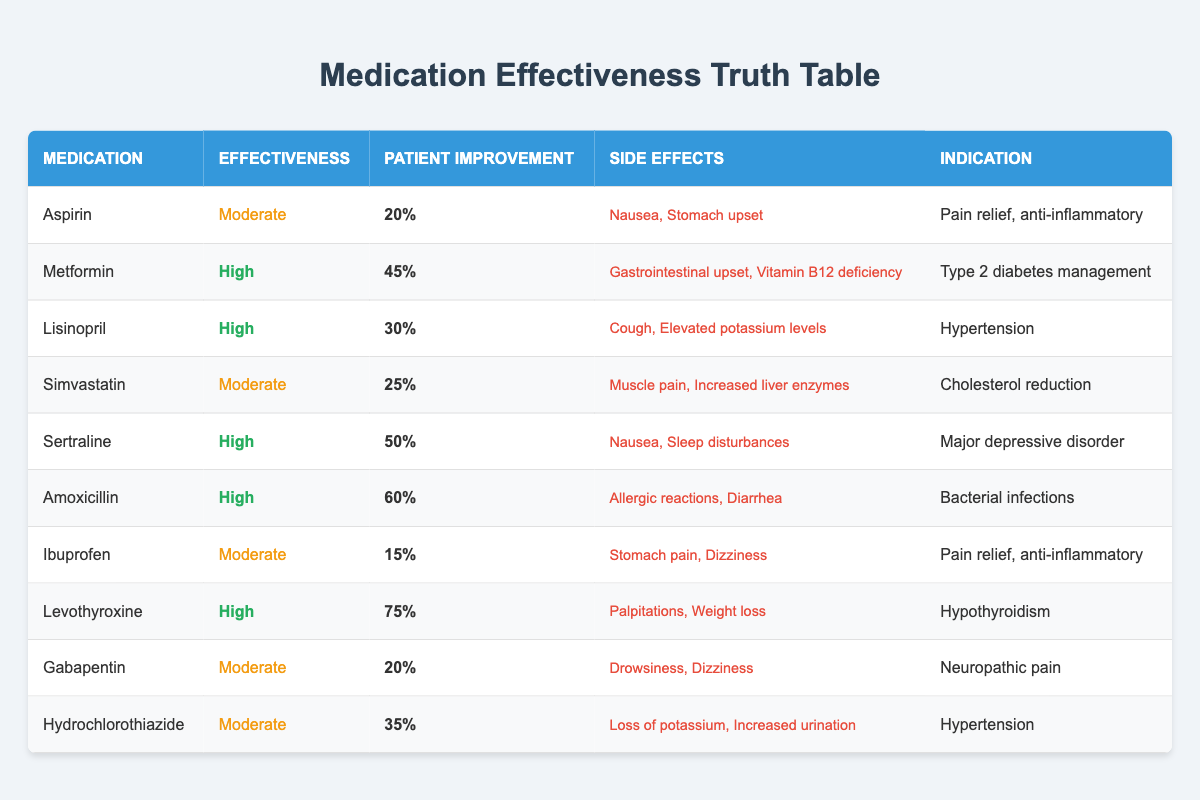What is the patient improvement percentage for Sertraline? The patient improvement percentage for Sertraline is found in the table under the "Patient Improvement" column next to Sertraline. It shows "50%".
Answer: 50% Which medication has the highest effectiveness rating? From the table, the effectiveness ratings are categorized as "High" and "Moderate." Scanning through the table, the medications that have a "High" effectiveness are Metformin, Lisinopril, Sertraline, Amoxicillin, and Levothyroxine. Therefore, there are multiple medications with the highest rating of "High".
Answer: Multiple medications have high effectiveness What is the improvement difference between Levothyroxine and Ibuprofen? To find the improvement difference, we subtract the patient improvement percentages. Levothyroxine has a patient improvement of "75%" and Ibuprofen has "15%." The difference is 75% - 15% = 60%.
Answer: 60% Is it true that Simvastatin has a higher patient improvement than Aspirin? Looking at the table, Simvastatin has a patient improvement of "25%" and Aspirin has "20%." Since 25% is greater than 20%, the statement is true.
Answer: True What fraction of the medications listed have "Moderate" effectiveness? Counting the total number of medications, there are 10 medications listed. The ones with "Moderate" effectiveness are Aspirin, Simvastatin, Ibuprofen, Gabapentin, and Hydrochlorothiazide. That makes 5 medications with a moderate effectiveness rating. The fraction is 5/10, which can be simplified to 1/2.
Answer: 1/2 What are the side effects of Amoxicillin? The side effects for Amoxicillin can be found in the table under the "Side Effects" column. It lists "Allergic reactions, Diarrhea."
Answer: Allergic reactions, Diarrhea Which two medications indicate pain relief? Scanning the table, we look for medications that have "Pain relief" listed under "Indication." Both Aspirin and Ibuprofen indicate pain relief.
Answer: Aspirin, Ibuprofen How does the efficacy of Metformin compare to Simvastatin? Metformin shows a patient improvement of "45%" and Simvastatin shows "25%." Comparing these values shows that Metformin has a higher efficacy as it leads to a greater percentage of patient improvement.
Answer: Metformin is more effective 